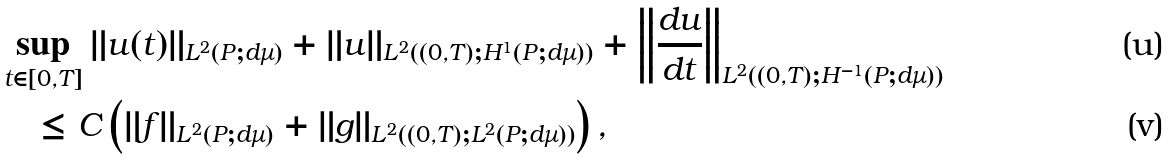Convert formula to latex. <formula><loc_0><loc_0><loc_500><loc_500>& \sup _ { t \in [ 0 , T ] } \| u ( t ) \| _ { L ^ { 2 } ( P ; d \mu ) } + \| u \| _ { L ^ { 2 } ( ( 0 , T ) ; H ^ { 1 } ( P ; d \mu ) ) } + \left \| \frac { d u } { d t } \right \| _ { L ^ { 2 } ( ( 0 , T ) ; H ^ { - 1 } ( P ; d \mu ) ) } \\ & \quad \leq C \left ( \| f \| _ { L ^ { 2 } ( P ; d \mu ) } + \| g \| _ { L ^ { 2 } ( ( 0 , T ) ; L ^ { 2 } ( P ; d \mu ) ) } \right ) ,</formula> 